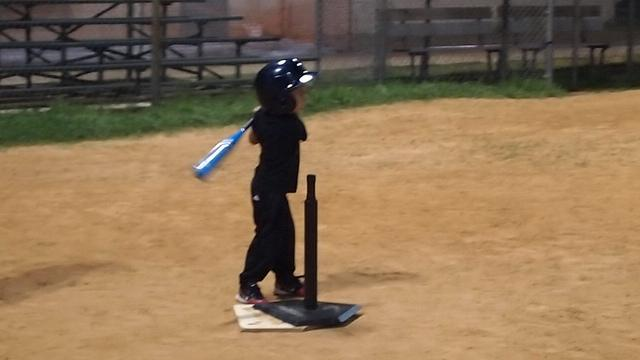Who would the child be more likely to admire? baseball player 